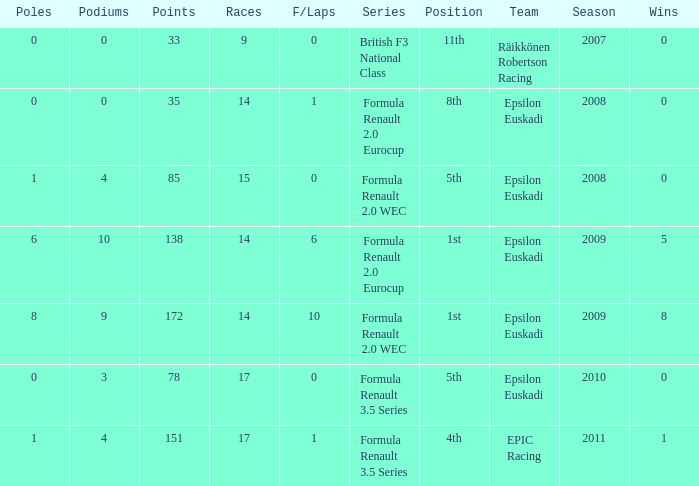What team was he on when he had 10 f/laps? Epsilon Euskadi. 